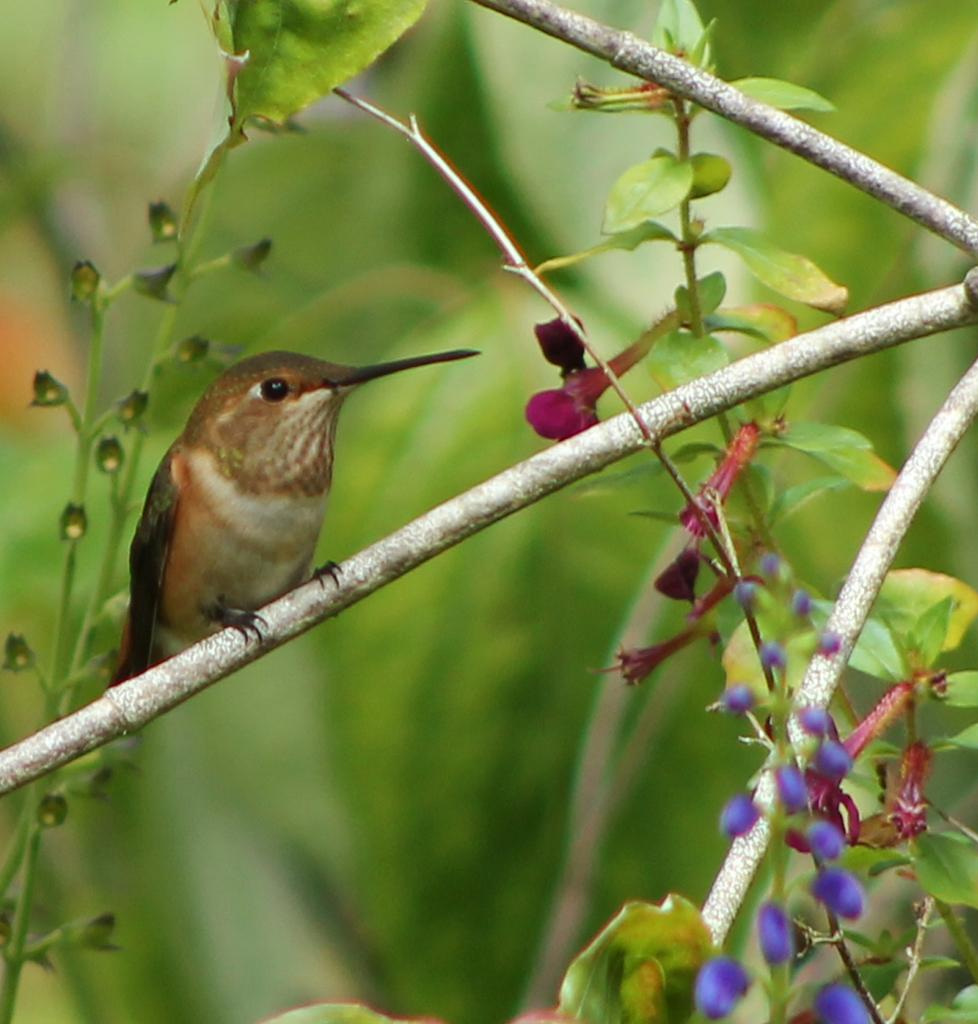What type of animal is in the image? There is a bird in the image. Where is the bird located? The bird is on a plant stem. Can you describe the background of the image? The background of the image is blurred, and the background color is green. What type of team is visible in the image? There is no team present in the image; it features a bird on a plant stem with a blurred, green background. 